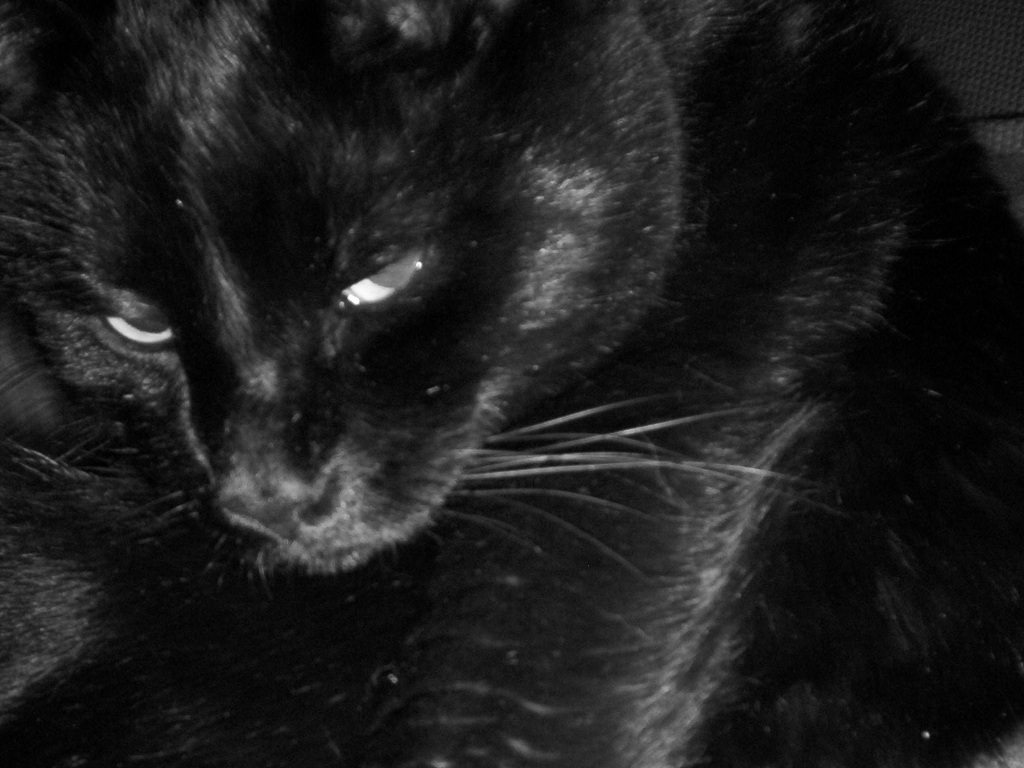Is the image of high quality? The image appears to be of moderate quality. It captures the subject with a good amount of detail, although the lighting is low and there is visible noise, which might be intentional to create a certain mood or effect. The focus seems to be on the eyes of the black cat, which are well-defined and make for a compelling subject. 